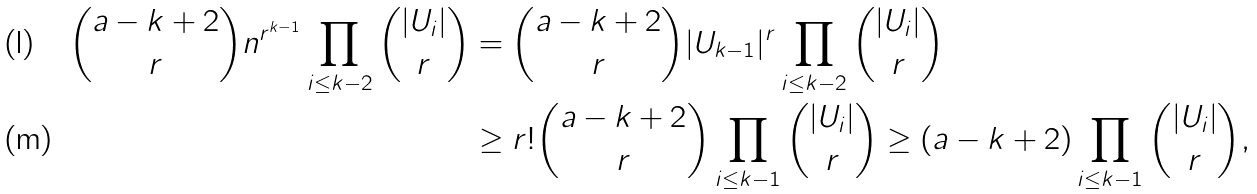<formula> <loc_0><loc_0><loc_500><loc_500>{ a - k + 2 \choose r } n ^ { r ^ { k - 1 } } \prod _ { i \leq k - 2 } { | U _ { i } | \choose r } & = { a - k + 2 \choose r } | U _ { k - 1 } | ^ { r } \prod _ { i \leq k - 2 } { | U _ { i } | \choose r } \\ & \geq r ! { a - k + 2 \choose r } \prod _ { i \leq k - 1 } { | U _ { i } | \choose r } \geq ( a - k + 2 ) \prod _ { i \leq k - 1 } { | U _ { i } | \choose r } ,</formula> 